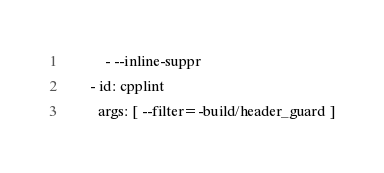Convert code to text. <code><loc_0><loc_0><loc_500><loc_500><_YAML_>          - --inline-suppr
      - id: cpplint
        args: [ --filter=-build/header_guard ]
</code> 